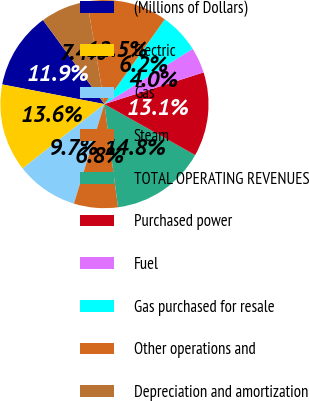Convert chart. <chart><loc_0><loc_0><loc_500><loc_500><pie_chart><fcel>(Millions of Dollars)<fcel>Electric<fcel>Gas<fcel>Steam<fcel>TOTAL OPERATING REVENUES<fcel>Purchased power<fcel>Fuel<fcel>Gas purchased for resale<fcel>Other operations and<fcel>Depreciation and amortization<nl><fcel>11.93%<fcel>13.63%<fcel>9.66%<fcel>6.82%<fcel>14.77%<fcel>13.07%<fcel>3.98%<fcel>6.25%<fcel>12.5%<fcel>7.39%<nl></chart> 